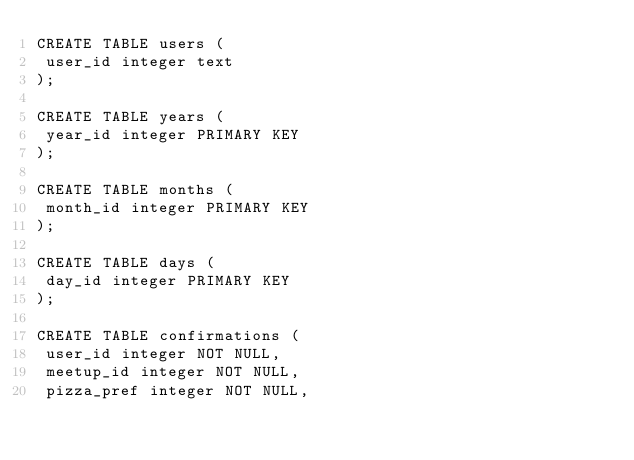<code> <loc_0><loc_0><loc_500><loc_500><_SQL_>CREATE TABLE users (
 user_id integer text 
);

CREATE TABLE years (
 year_id integer PRIMARY KEY
);

CREATE TABLE months (
 month_id integer PRIMARY KEY
);

CREATE TABLE days (
 day_id integer PRIMARY KEY
);

CREATE TABLE confirmations (
 user_id integer NOT NULL,
 meetup_id integer NOT NULL,
 pizza_pref integer NOT NULL,</code> 